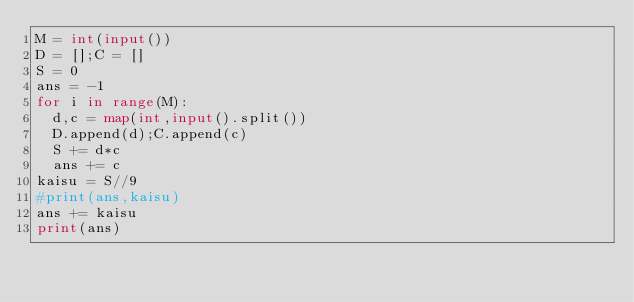Convert code to text. <code><loc_0><loc_0><loc_500><loc_500><_Python_>M = int(input())
D = [];C = []
S = 0
ans = -1
for i in range(M):
  d,c = map(int,input().split())
  D.append(d);C.append(c)
  S += d*c
  ans += c
kaisu = S//9
#print(ans,kaisu)
ans += kaisu
print(ans)
</code> 